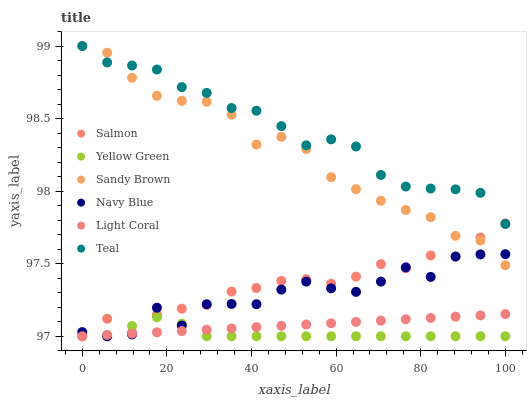Does Yellow Green have the minimum area under the curve?
Answer yes or no. Yes. Does Teal have the maximum area under the curve?
Answer yes or no. Yes. Does Navy Blue have the minimum area under the curve?
Answer yes or no. No. Does Navy Blue have the maximum area under the curve?
Answer yes or no. No. Is Light Coral the smoothest?
Answer yes or no. Yes. Is Navy Blue the roughest?
Answer yes or no. Yes. Is Salmon the smoothest?
Answer yes or no. No. Is Salmon the roughest?
Answer yes or no. No. Does Yellow Green have the lowest value?
Answer yes or no. Yes. Does Teal have the lowest value?
Answer yes or no. No. Does Sandy Brown have the highest value?
Answer yes or no. Yes. Does Navy Blue have the highest value?
Answer yes or no. No. Is Navy Blue less than Teal?
Answer yes or no. Yes. Is Teal greater than Yellow Green?
Answer yes or no. Yes. Does Yellow Green intersect Light Coral?
Answer yes or no. Yes. Is Yellow Green less than Light Coral?
Answer yes or no. No. Is Yellow Green greater than Light Coral?
Answer yes or no. No. Does Navy Blue intersect Teal?
Answer yes or no. No. 